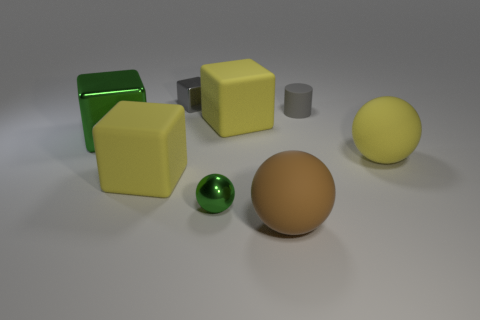The small gray metal object that is behind the green object in front of the big green block is what shape? cube 